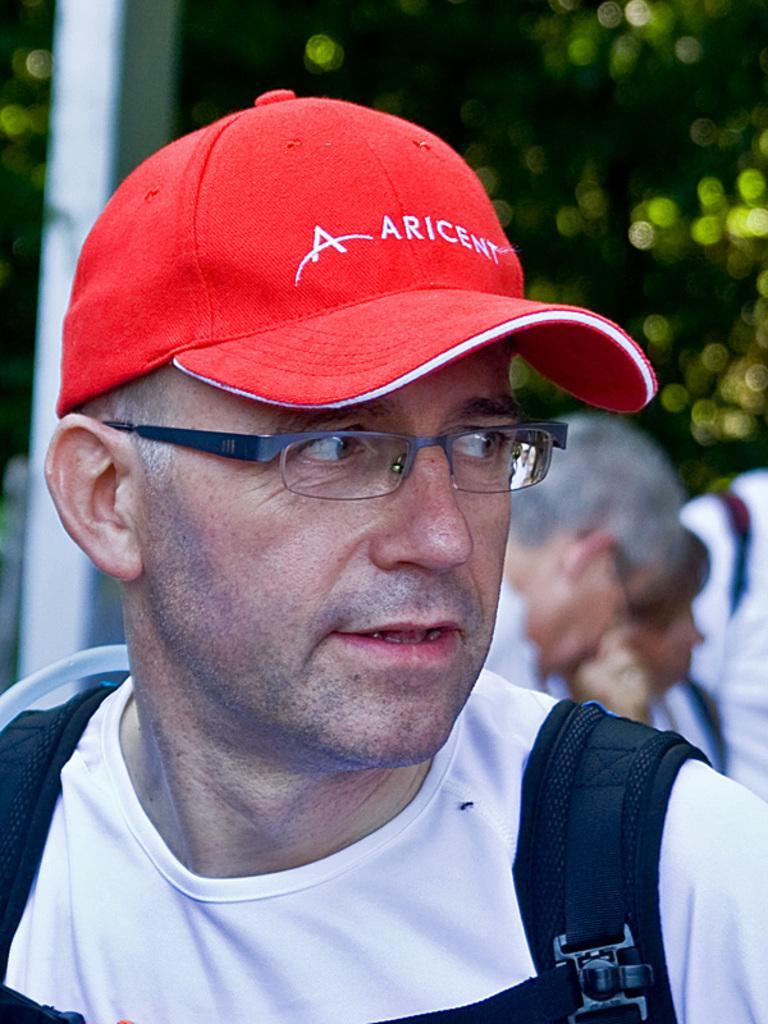Please provide a concise description of this image. In the middle of this image, there is a person in a white color T-shirt and wearing an orange color cap. In the background, there are other persons. And the background is blurred. 